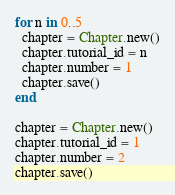Convert code to text. <code><loc_0><loc_0><loc_500><loc_500><_Ruby_>
for n in 0..5
  chapter = Chapter.new()
  chapter.tutorial_id = n
  chapter.number = 1
  chapter.save()
end

chapter = Chapter.new()
chapter.tutorial_id = 1
chapter.number = 2
chapter.save()</code> 